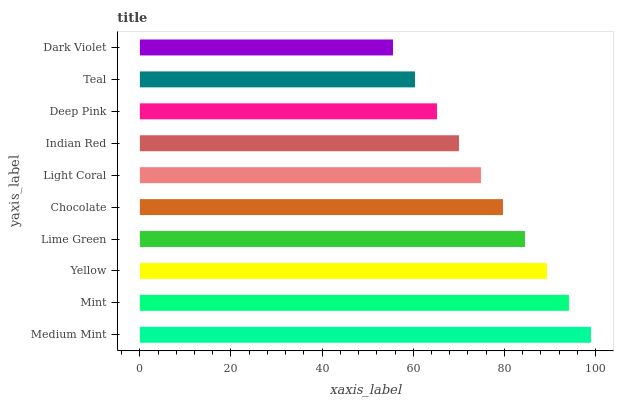Is Dark Violet the minimum?
Answer yes or no. Yes. Is Medium Mint the maximum?
Answer yes or no. Yes. Is Mint the minimum?
Answer yes or no. No. Is Mint the maximum?
Answer yes or no. No. Is Medium Mint greater than Mint?
Answer yes or no. Yes. Is Mint less than Medium Mint?
Answer yes or no. Yes. Is Mint greater than Medium Mint?
Answer yes or no. No. Is Medium Mint less than Mint?
Answer yes or no. No. Is Chocolate the high median?
Answer yes or no. Yes. Is Light Coral the low median?
Answer yes or no. Yes. Is Medium Mint the high median?
Answer yes or no. No. Is Lime Green the low median?
Answer yes or no. No. 